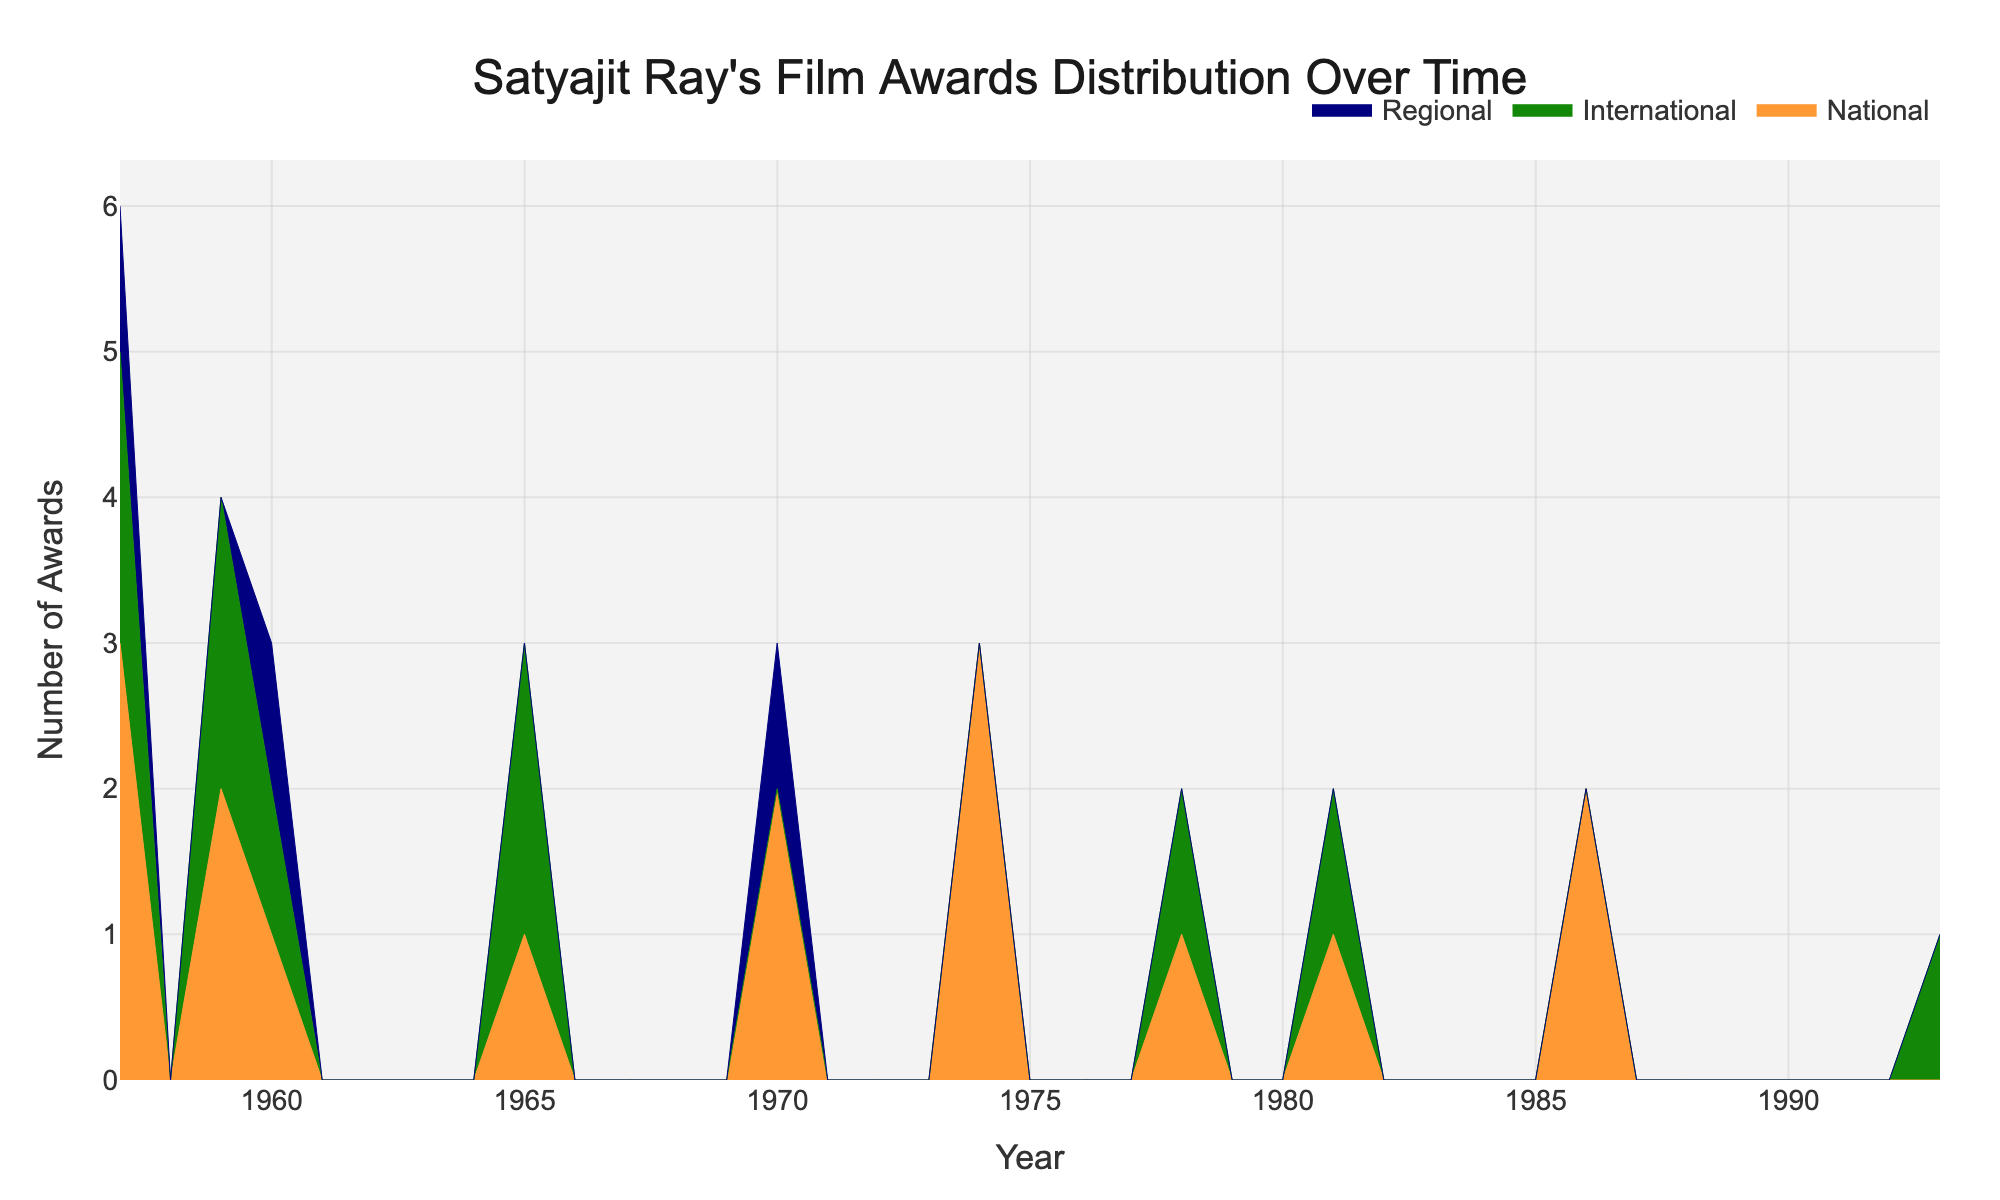What is the title of the chart? The title of the chart is usually located at the top center of the figure. It provides a concise description of what the chart is about. In this case, the title is: "Satyajit Ray's Film Awards Distribution Over Time."
Answer: Satyajit Ray's Film Awards Distribution Over Time What are the x-axis and y-axis representing in this chart? The x-axis represents the timeline, specifically the years, as indicated by the equally spaced ticks labeled by four-digit years (e.g., 1956, 1958). The y-axis represents the number of awards won, as indicated by the label "Number of Awards."
Answer: Years and Number of Awards Which award type has the highest number of awards in 1956? By examining the stacked area chart, we can see the different colored areas representing National, International, and Regional awards. In 1956, the area for National awards appears to be the largest.
Answer: National How many total awards were won by Satyajit Ray's movies in the year 1956? To find the total awards in 1956, we add the number of National, International, and Regional awards. From the dataset, we see: 3 (National) + 2 (International) + 1 (Regional) = 6 awards.
Answer: 6 awards Between 1956 and 1959, which had more awards: National or International? To compare the total National and International awards between 1956 and 1959, sum the respective awards from the years 1956, 1958, and 1959. National: 3+2+1+2=8 awards, International: 2+2+1=5 awards. National has more awards.
Answer: National In which year did Satyajit Ray win the Honorary Oscar, and how many awards did he win that year in total? According to the dataset, Satyajit Ray won the Honorary Oscar in 1992. Since it is the only award listed for that year, the total number of awards in 1992 is 1.
Answer: 1992, 1 award Is there any year where Ray's movies won awards in all three categories: National, International, and Regional? We look for a year in the dataset where awards are listed for National, International, and Regional categories. In 1956, there are awards for all three categories: National (3), International (2), Regional (1).
Answer: 1956 Which award type saw an increased number of awards from 1964 to 1969? We compare the number of awards for each type between 1964 and 1969. National: 1 (1964) to 2 (1969); International: 2 (1964) to 0 (1969); Regional: 0 (1964) to 1 (1969). Hence, National and Regional awards both increased.
Answer: National and Regional What is the color representing International awards in the chart? The color used for International awards can be seen in the chart's legend or by identifying the color of the area labeled "International." It is typically shown in a specific unique color. Here, it is a shade of green (#138808).
Answer: Green 